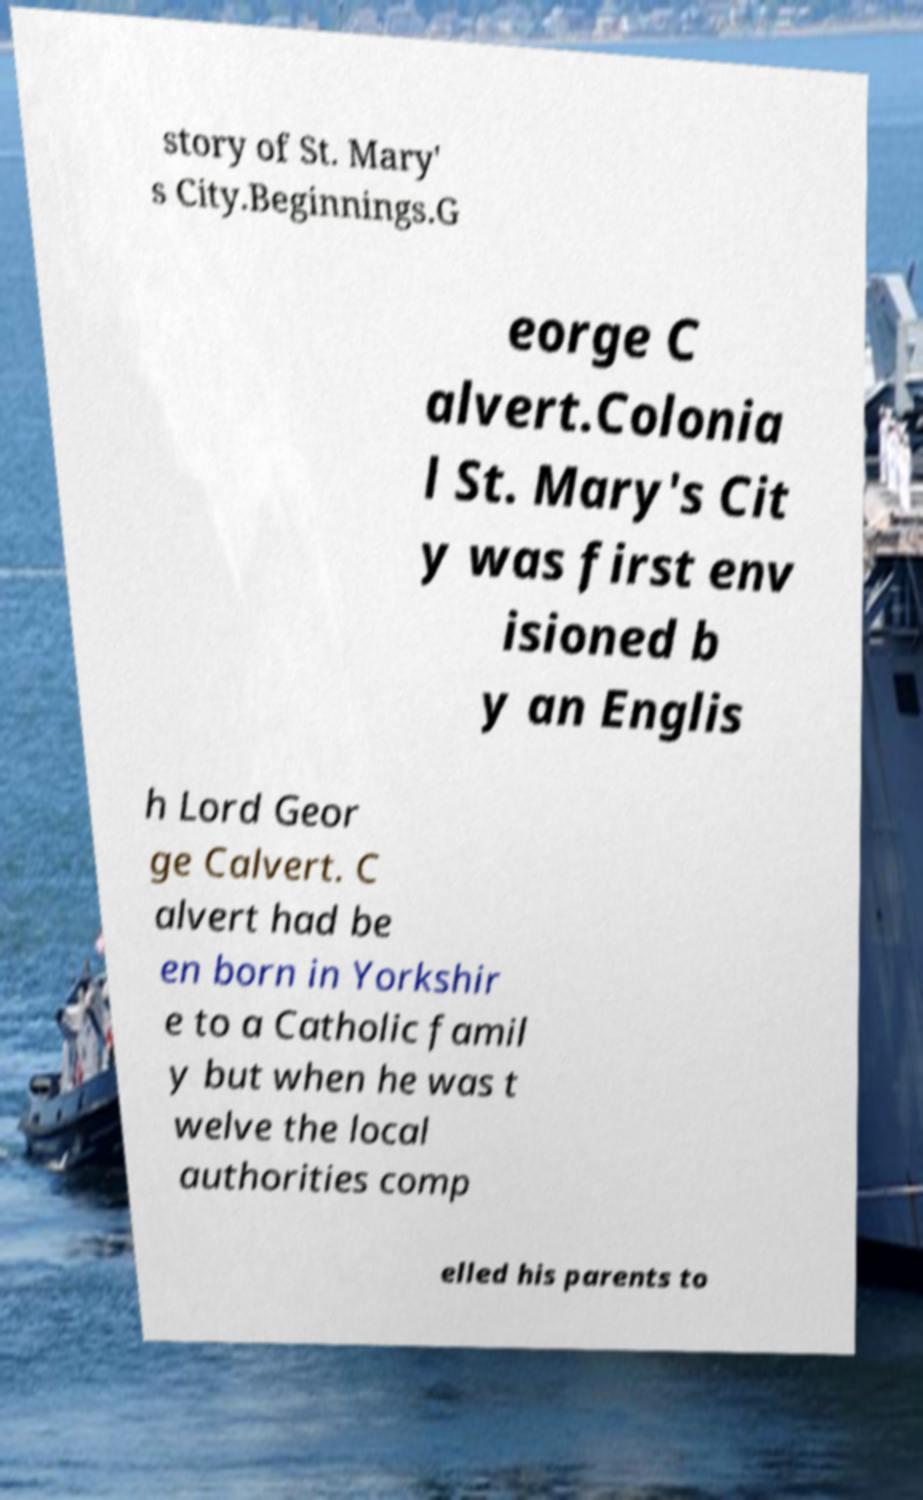Please identify and transcribe the text found in this image. story of St. Mary' s City.Beginnings.G eorge C alvert.Colonia l St. Mary's Cit y was first env isioned b y an Englis h Lord Geor ge Calvert. C alvert had be en born in Yorkshir e to a Catholic famil y but when he was t welve the local authorities comp elled his parents to 